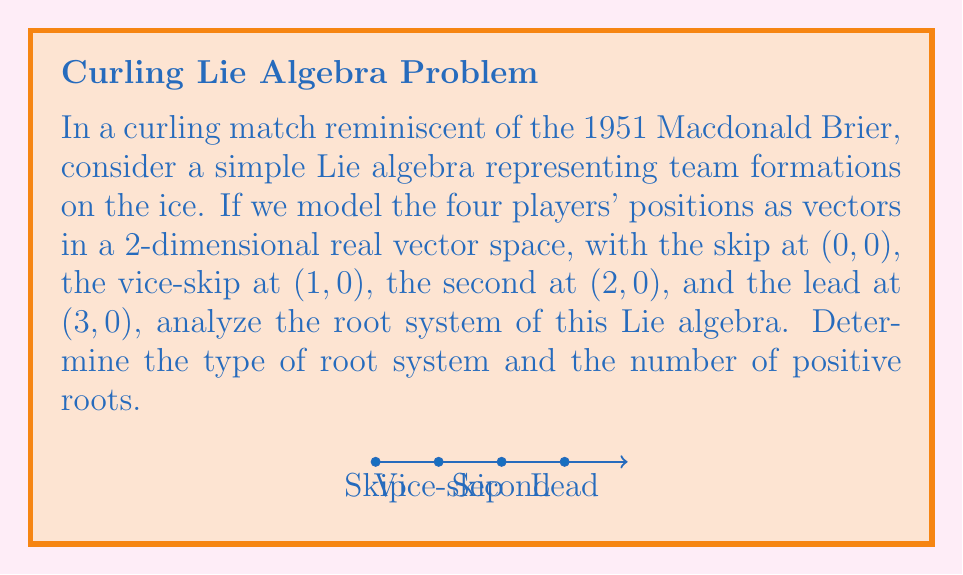Can you solve this math problem? Let's approach this step-by-step:

1) First, we need to identify the Lie algebra type. Given the 2-dimensional real vector space and the linear arrangement of players, this corresponds to the $A_3$ Lie algebra (or $\mathfrak{sl}_4(\mathbb{R})$).

2) The root system of $A_3$ consists of vectors in a 3-dimensional space. We can represent these roots as:

   $\alpha_1 = (1, -1, 0)$
   $\alpha_2 = (0, 1, -1)$
   $\alpha_3 = (0, 0, 1)$

3) These are the simple roots of the system. The positive roots are:

   $\alpha_1 = (1, -1, 0)$
   $\alpha_2 = (0, 1, -1)$
   $\alpha_3 = (0, 0, 1)$
   $\alpha_1 + \alpha_2 = (1, 0, -1)$
   $\alpha_2 + \alpha_3 = (0, 1, 0)$
   $\alpha_1 + \alpha_2 + \alpha_3 = (1, 0, 0)$

4) To count the number of positive roots, we simply need to count these vectors. There are 6 positive roots.

5) The root system of $A_3$ is characterized by having roots of two different lengths, forming a triangular shape when projected onto a plane perpendicular to the longest root.

Therefore, the root system is of type $A_3$, which corresponds to the special linear group $SL(4, \mathbb{R})$ or its Lie algebra $\mathfrak{sl}_4(\mathbb{R})$.
Answer: Type $A_3$ root system with 6 positive roots. 